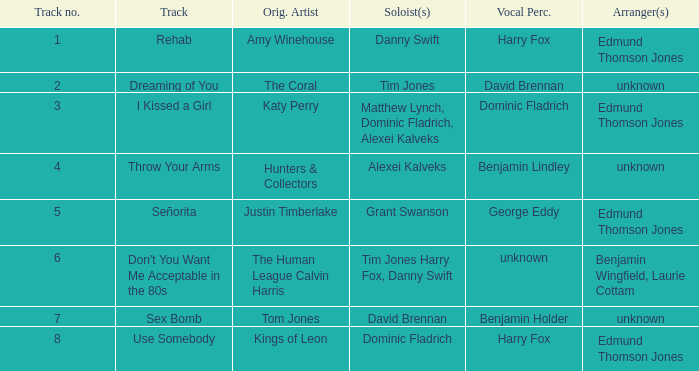Who is the percussionist for The Coral? David Brennan. 